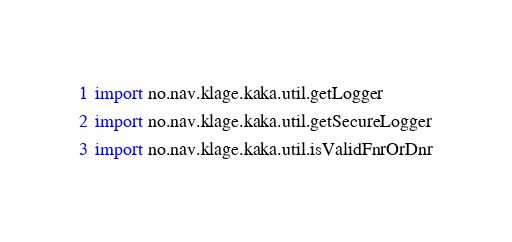<code> <loc_0><loc_0><loc_500><loc_500><_Kotlin_>import no.nav.klage.kaka.util.getLogger
import no.nav.klage.kaka.util.getSecureLogger
import no.nav.klage.kaka.util.isValidFnrOrDnr</code> 